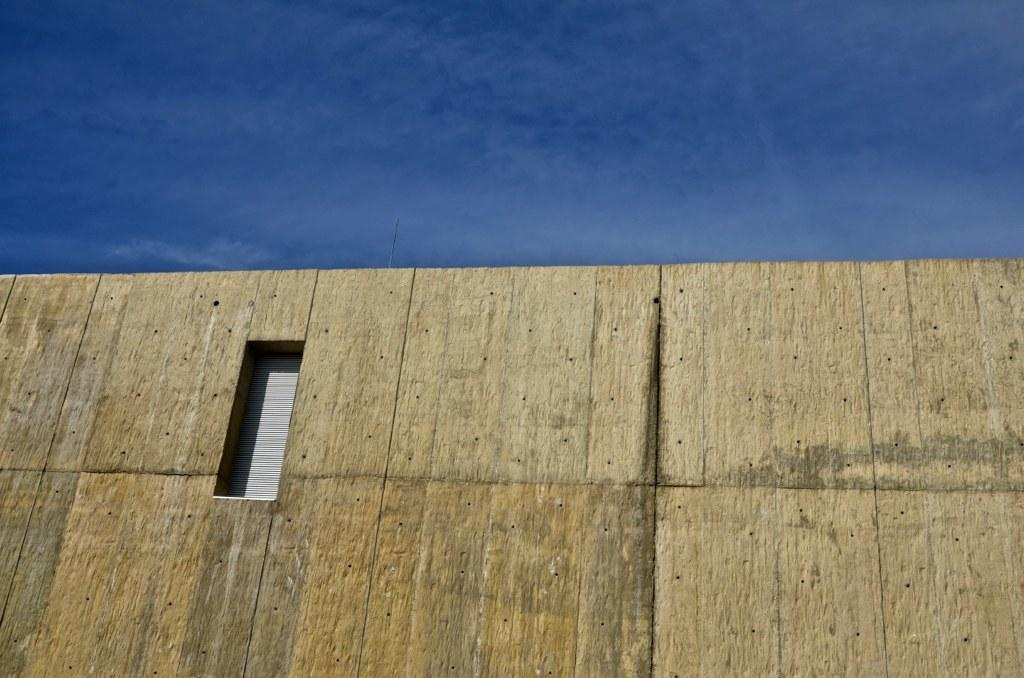What type of structure can be seen in the image? There is a wall in the image. Is there any opening in the wall? Yes, there is a window in the wall. What can be seen beyond the wall and window? The sky is visible at the top of the image. What type of screw is being offered by the wall in the image? There is no screw present in the image; it only features a wall and a window. 